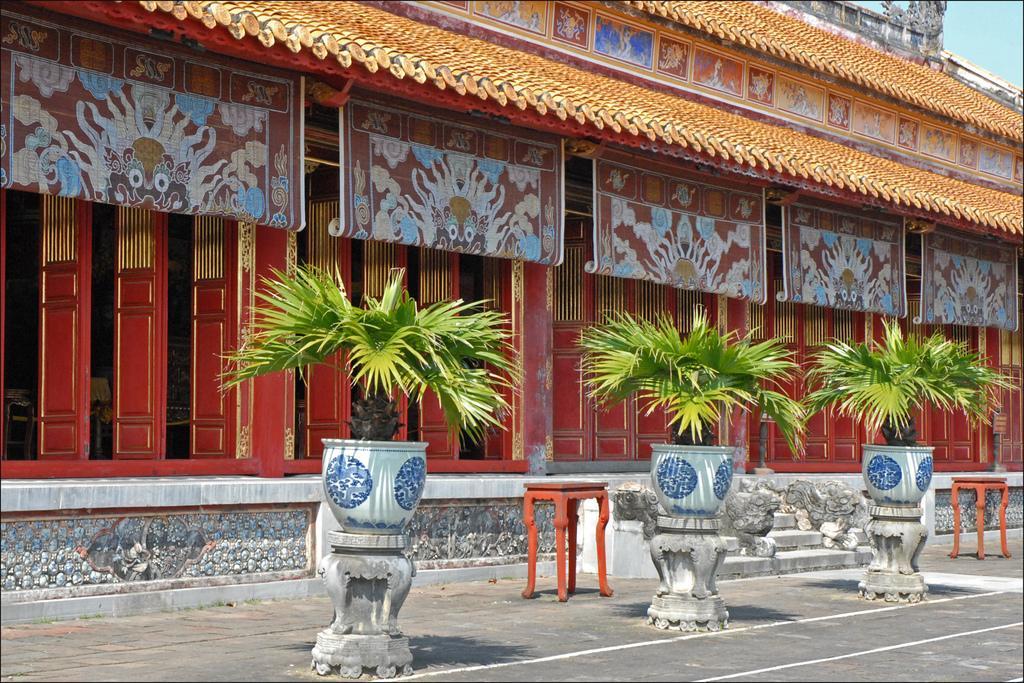How would you summarize this image in a sentence or two? There are plant pots, 2 stools, stairs and a building. 